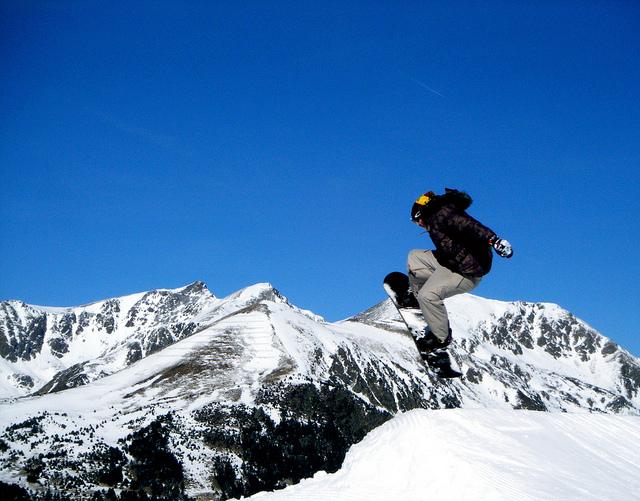Is this man wearing enough warm gear?
Quick response, please. Yes. Where are the trees?
Short answer required. Nowhere. What sport are they doing?
Answer briefly. Snowboarding. What is attached to this person's feet?
Quick response, please. Snowboard. What size will the storm be?
Be succinct. Small. 